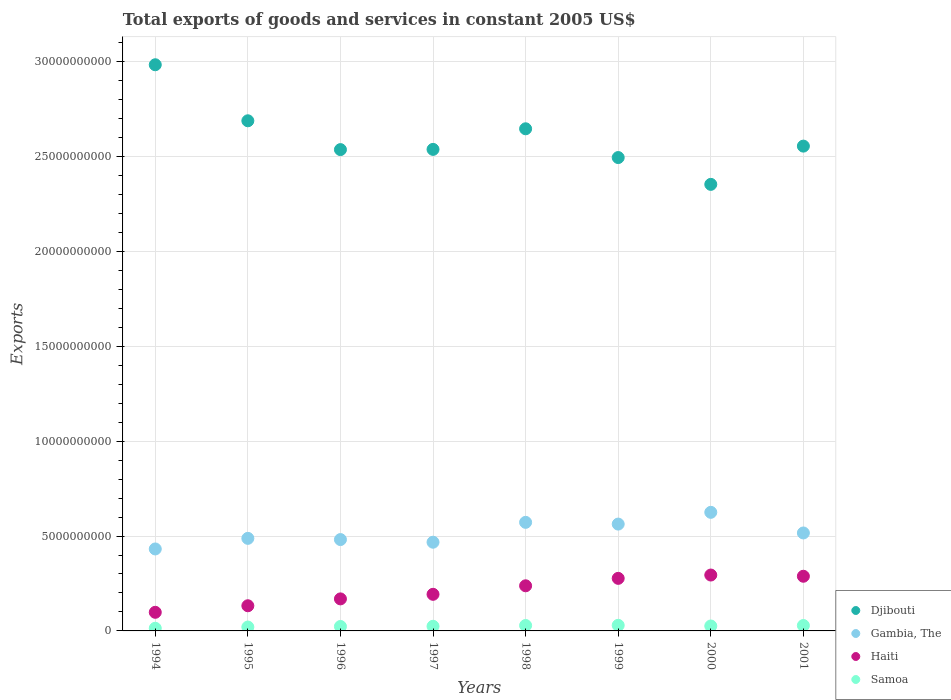Is the number of dotlines equal to the number of legend labels?
Provide a short and direct response. Yes. What is the total exports of goods and services in Haiti in 2000?
Keep it short and to the point. 2.94e+09. Across all years, what is the maximum total exports of goods and services in Gambia, The?
Ensure brevity in your answer.  6.25e+09. Across all years, what is the minimum total exports of goods and services in Gambia, The?
Your answer should be compact. 4.32e+09. In which year was the total exports of goods and services in Haiti maximum?
Ensure brevity in your answer.  2000. In which year was the total exports of goods and services in Djibouti minimum?
Provide a succinct answer. 2000. What is the total total exports of goods and services in Haiti in the graph?
Make the answer very short. 1.69e+1. What is the difference between the total exports of goods and services in Gambia, The in 1996 and that in 2001?
Offer a terse response. -3.48e+08. What is the difference between the total exports of goods and services in Gambia, The in 1997 and the total exports of goods and services in Haiti in 2000?
Provide a short and direct response. 1.73e+09. What is the average total exports of goods and services in Gambia, The per year?
Make the answer very short. 5.18e+09. In the year 2001, what is the difference between the total exports of goods and services in Djibouti and total exports of goods and services in Samoa?
Give a very brief answer. 2.53e+1. In how many years, is the total exports of goods and services in Samoa greater than 22000000000 US$?
Your answer should be very brief. 0. What is the ratio of the total exports of goods and services in Haiti in 1997 to that in 2001?
Provide a short and direct response. 0.67. Is the difference between the total exports of goods and services in Djibouti in 1995 and 2001 greater than the difference between the total exports of goods and services in Samoa in 1995 and 2001?
Ensure brevity in your answer.  Yes. What is the difference between the highest and the second highest total exports of goods and services in Haiti?
Provide a short and direct response. 6.40e+07. What is the difference between the highest and the lowest total exports of goods and services in Samoa?
Your response must be concise. 1.55e+08. In how many years, is the total exports of goods and services in Samoa greater than the average total exports of goods and services in Samoa taken over all years?
Offer a terse response. 5. Is the sum of the total exports of goods and services in Gambia, The in 1996 and 1999 greater than the maximum total exports of goods and services in Haiti across all years?
Provide a short and direct response. Yes. Is it the case that in every year, the sum of the total exports of goods and services in Djibouti and total exports of goods and services in Haiti  is greater than the total exports of goods and services in Samoa?
Offer a very short reply. Yes. Is the total exports of goods and services in Samoa strictly greater than the total exports of goods and services in Haiti over the years?
Offer a very short reply. No. Is the total exports of goods and services in Gambia, The strictly less than the total exports of goods and services in Haiti over the years?
Your answer should be very brief. No. How many dotlines are there?
Provide a succinct answer. 4. What is the difference between two consecutive major ticks on the Y-axis?
Keep it short and to the point. 5.00e+09. Does the graph contain grids?
Your response must be concise. Yes. What is the title of the graph?
Your answer should be very brief. Total exports of goods and services in constant 2005 US$. Does "United States" appear as one of the legend labels in the graph?
Keep it short and to the point. No. What is the label or title of the X-axis?
Provide a short and direct response. Years. What is the label or title of the Y-axis?
Offer a very short reply. Exports. What is the Exports in Djibouti in 1994?
Your response must be concise. 2.98e+1. What is the Exports in Gambia, The in 1994?
Provide a short and direct response. 4.32e+09. What is the Exports of Haiti in 1994?
Give a very brief answer. 9.81e+08. What is the Exports in Samoa in 1994?
Offer a terse response. 1.40e+08. What is the Exports in Djibouti in 1995?
Offer a very short reply. 2.69e+1. What is the Exports in Gambia, The in 1995?
Offer a terse response. 4.88e+09. What is the Exports of Haiti in 1995?
Offer a terse response. 1.33e+09. What is the Exports of Samoa in 1995?
Ensure brevity in your answer.  2.05e+08. What is the Exports of Djibouti in 1996?
Ensure brevity in your answer.  2.54e+1. What is the Exports of Gambia, The in 1996?
Offer a terse response. 4.81e+09. What is the Exports in Haiti in 1996?
Offer a very short reply. 1.69e+09. What is the Exports of Samoa in 1996?
Keep it short and to the point. 2.34e+08. What is the Exports of Djibouti in 1997?
Give a very brief answer. 2.54e+1. What is the Exports of Gambia, The in 1997?
Give a very brief answer. 4.67e+09. What is the Exports of Haiti in 1997?
Your answer should be very brief. 1.93e+09. What is the Exports in Samoa in 1997?
Your answer should be compact. 2.44e+08. What is the Exports of Djibouti in 1998?
Provide a succinct answer. 2.65e+1. What is the Exports of Gambia, The in 1998?
Keep it short and to the point. 5.72e+09. What is the Exports in Haiti in 1998?
Offer a very short reply. 2.38e+09. What is the Exports in Samoa in 1998?
Keep it short and to the point. 2.86e+08. What is the Exports of Djibouti in 1999?
Your response must be concise. 2.49e+1. What is the Exports in Gambia, The in 1999?
Offer a terse response. 5.63e+09. What is the Exports of Haiti in 1999?
Make the answer very short. 2.77e+09. What is the Exports of Samoa in 1999?
Your answer should be very brief. 2.95e+08. What is the Exports of Djibouti in 2000?
Make the answer very short. 2.35e+1. What is the Exports of Gambia, The in 2000?
Provide a short and direct response. 6.25e+09. What is the Exports in Haiti in 2000?
Your response must be concise. 2.94e+09. What is the Exports in Samoa in 2000?
Give a very brief answer. 2.60e+08. What is the Exports of Djibouti in 2001?
Offer a very short reply. 2.55e+1. What is the Exports of Gambia, The in 2001?
Make the answer very short. 5.16e+09. What is the Exports in Haiti in 2001?
Provide a short and direct response. 2.88e+09. What is the Exports in Samoa in 2001?
Provide a short and direct response. 2.85e+08. Across all years, what is the maximum Exports of Djibouti?
Your answer should be compact. 2.98e+1. Across all years, what is the maximum Exports of Gambia, The?
Your answer should be very brief. 6.25e+09. Across all years, what is the maximum Exports in Haiti?
Give a very brief answer. 2.94e+09. Across all years, what is the maximum Exports in Samoa?
Your response must be concise. 2.95e+08. Across all years, what is the minimum Exports in Djibouti?
Ensure brevity in your answer.  2.35e+1. Across all years, what is the minimum Exports in Gambia, The?
Make the answer very short. 4.32e+09. Across all years, what is the minimum Exports of Haiti?
Your answer should be very brief. 9.81e+08. Across all years, what is the minimum Exports in Samoa?
Offer a terse response. 1.40e+08. What is the total Exports of Djibouti in the graph?
Offer a terse response. 2.08e+11. What is the total Exports of Gambia, The in the graph?
Your answer should be very brief. 4.14e+1. What is the total Exports in Haiti in the graph?
Offer a very short reply. 1.69e+1. What is the total Exports of Samoa in the graph?
Your answer should be very brief. 1.95e+09. What is the difference between the Exports in Djibouti in 1994 and that in 1995?
Provide a succinct answer. 2.95e+09. What is the difference between the Exports in Gambia, The in 1994 and that in 1995?
Provide a short and direct response. -5.58e+08. What is the difference between the Exports in Haiti in 1994 and that in 1995?
Keep it short and to the point. -3.45e+08. What is the difference between the Exports of Samoa in 1994 and that in 1995?
Offer a very short reply. -6.46e+07. What is the difference between the Exports in Djibouti in 1994 and that in 1996?
Give a very brief answer. 4.47e+09. What is the difference between the Exports in Gambia, The in 1994 and that in 1996?
Make the answer very short. -4.95e+08. What is the difference between the Exports of Haiti in 1994 and that in 1996?
Offer a very short reply. -7.07e+08. What is the difference between the Exports in Samoa in 1994 and that in 1996?
Offer a very short reply. -9.42e+07. What is the difference between the Exports of Djibouti in 1994 and that in 1997?
Keep it short and to the point. 4.46e+09. What is the difference between the Exports of Gambia, The in 1994 and that in 1997?
Ensure brevity in your answer.  -3.55e+08. What is the difference between the Exports of Haiti in 1994 and that in 1997?
Offer a terse response. -9.48e+08. What is the difference between the Exports of Samoa in 1994 and that in 1997?
Give a very brief answer. -1.04e+08. What is the difference between the Exports of Djibouti in 1994 and that in 1998?
Provide a succinct answer. 3.37e+09. What is the difference between the Exports of Gambia, The in 1994 and that in 1998?
Keep it short and to the point. -1.40e+09. What is the difference between the Exports of Haiti in 1994 and that in 1998?
Your response must be concise. -1.40e+09. What is the difference between the Exports of Samoa in 1994 and that in 1998?
Give a very brief answer. -1.46e+08. What is the difference between the Exports of Djibouti in 1994 and that in 1999?
Your response must be concise. 4.89e+09. What is the difference between the Exports in Gambia, The in 1994 and that in 1999?
Provide a short and direct response. -1.31e+09. What is the difference between the Exports in Haiti in 1994 and that in 1999?
Offer a terse response. -1.79e+09. What is the difference between the Exports in Samoa in 1994 and that in 1999?
Give a very brief answer. -1.55e+08. What is the difference between the Exports in Djibouti in 1994 and that in 2000?
Your response must be concise. 6.30e+09. What is the difference between the Exports in Gambia, The in 1994 and that in 2000?
Offer a very short reply. -1.93e+09. What is the difference between the Exports in Haiti in 1994 and that in 2000?
Provide a short and direct response. -1.96e+09. What is the difference between the Exports of Samoa in 1994 and that in 2000?
Offer a terse response. -1.20e+08. What is the difference between the Exports of Djibouti in 1994 and that in 2001?
Your response must be concise. 4.29e+09. What is the difference between the Exports in Gambia, The in 1994 and that in 2001?
Give a very brief answer. -8.43e+08. What is the difference between the Exports of Haiti in 1994 and that in 2001?
Make the answer very short. -1.90e+09. What is the difference between the Exports in Samoa in 1994 and that in 2001?
Your answer should be compact. -1.45e+08. What is the difference between the Exports of Djibouti in 1995 and that in 1996?
Offer a very short reply. 1.52e+09. What is the difference between the Exports of Gambia, The in 1995 and that in 1996?
Offer a very short reply. 6.37e+07. What is the difference between the Exports in Haiti in 1995 and that in 1996?
Give a very brief answer. -3.62e+08. What is the difference between the Exports of Samoa in 1995 and that in 1996?
Offer a terse response. -2.96e+07. What is the difference between the Exports in Djibouti in 1995 and that in 1997?
Offer a terse response. 1.51e+09. What is the difference between the Exports of Gambia, The in 1995 and that in 1997?
Provide a short and direct response. 2.03e+08. What is the difference between the Exports in Haiti in 1995 and that in 1997?
Ensure brevity in your answer.  -6.03e+08. What is the difference between the Exports in Samoa in 1995 and that in 1997?
Your answer should be very brief. -3.93e+07. What is the difference between the Exports in Djibouti in 1995 and that in 1998?
Provide a succinct answer. 4.22e+08. What is the difference between the Exports in Gambia, The in 1995 and that in 1998?
Keep it short and to the point. -8.44e+08. What is the difference between the Exports of Haiti in 1995 and that in 1998?
Provide a short and direct response. -1.05e+09. What is the difference between the Exports of Samoa in 1995 and that in 1998?
Ensure brevity in your answer.  -8.16e+07. What is the difference between the Exports of Djibouti in 1995 and that in 1999?
Provide a succinct answer. 1.94e+09. What is the difference between the Exports of Gambia, The in 1995 and that in 1999?
Offer a terse response. -7.52e+08. What is the difference between the Exports in Haiti in 1995 and that in 1999?
Keep it short and to the point. -1.44e+09. What is the difference between the Exports of Samoa in 1995 and that in 1999?
Your response must be concise. -9.07e+07. What is the difference between the Exports of Djibouti in 1995 and that in 2000?
Make the answer very short. 3.35e+09. What is the difference between the Exports of Gambia, The in 1995 and that in 2000?
Keep it short and to the point. -1.37e+09. What is the difference between the Exports in Haiti in 1995 and that in 2000?
Ensure brevity in your answer.  -1.62e+09. What is the difference between the Exports in Samoa in 1995 and that in 2000?
Give a very brief answer. -5.55e+07. What is the difference between the Exports in Djibouti in 1995 and that in 2001?
Offer a terse response. 1.34e+09. What is the difference between the Exports in Gambia, The in 1995 and that in 2001?
Ensure brevity in your answer.  -2.84e+08. What is the difference between the Exports of Haiti in 1995 and that in 2001?
Offer a very short reply. -1.56e+09. What is the difference between the Exports of Samoa in 1995 and that in 2001?
Your response must be concise. -8.03e+07. What is the difference between the Exports of Djibouti in 1996 and that in 1997?
Your answer should be compact. -1.16e+07. What is the difference between the Exports of Gambia, The in 1996 and that in 1997?
Provide a succinct answer. 1.40e+08. What is the difference between the Exports in Haiti in 1996 and that in 1997?
Ensure brevity in your answer.  -2.41e+08. What is the difference between the Exports of Samoa in 1996 and that in 1997?
Provide a succinct answer. -9.63e+06. What is the difference between the Exports in Djibouti in 1996 and that in 1998?
Your answer should be very brief. -1.10e+09. What is the difference between the Exports in Gambia, The in 1996 and that in 1998?
Your answer should be very brief. -9.07e+08. What is the difference between the Exports of Haiti in 1996 and that in 1998?
Keep it short and to the point. -6.90e+08. What is the difference between the Exports in Samoa in 1996 and that in 1998?
Your response must be concise. -5.19e+07. What is the difference between the Exports in Djibouti in 1996 and that in 1999?
Offer a very short reply. 4.19e+08. What is the difference between the Exports in Gambia, The in 1996 and that in 1999?
Your answer should be very brief. -8.16e+08. What is the difference between the Exports of Haiti in 1996 and that in 1999?
Your answer should be compact. -1.08e+09. What is the difference between the Exports in Samoa in 1996 and that in 1999?
Your response must be concise. -6.11e+07. What is the difference between the Exports of Djibouti in 1996 and that in 2000?
Provide a succinct answer. 1.83e+09. What is the difference between the Exports in Gambia, The in 1996 and that in 2000?
Make the answer very short. -1.44e+09. What is the difference between the Exports in Haiti in 1996 and that in 2000?
Your answer should be compact. -1.26e+09. What is the difference between the Exports of Samoa in 1996 and that in 2000?
Your response must be concise. -2.59e+07. What is the difference between the Exports in Djibouti in 1996 and that in 2001?
Offer a terse response. -1.84e+08. What is the difference between the Exports in Gambia, The in 1996 and that in 2001?
Provide a succinct answer. -3.48e+08. What is the difference between the Exports in Haiti in 1996 and that in 2001?
Your answer should be compact. -1.19e+09. What is the difference between the Exports of Samoa in 1996 and that in 2001?
Provide a short and direct response. -5.07e+07. What is the difference between the Exports of Djibouti in 1997 and that in 1998?
Make the answer very short. -1.09e+09. What is the difference between the Exports of Gambia, The in 1997 and that in 1998?
Make the answer very short. -1.05e+09. What is the difference between the Exports in Haiti in 1997 and that in 1998?
Keep it short and to the point. -4.49e+08. What is the difference between the Exports in Samoa in 1997 and that in 1998?
Ensure brevity in your answer.  -4.23e+07. What is the difference between the Exports in Djibouti in 1997 and that in 1999?
Your answer should be compact. 4.30e+08. What is the difference between the Exports of Gambia, The in 1997 and that in 1999?
Your answer should be very brief. -9.56e+08. What is the difference between the Exports of Haiti in 1997 and that in 1999?
Provide a succinct answer. -8.41e+08. What is the difference between the Exports in Samoa in 1997 and that in 1999?
Ensure brevity in your answer.  -5.15e+07. What is the difference between the Exports in Djibouti in 1997 and that in 2000?
Give a very brief answer. 1.84e+09. What is the difference between the Exports of Gambia, The in 1997 and that in 2000?
Make the answer very short. -1.57e+09. What is the difference between the Exports in Haiti in 1997 and that in 2000?
Ensure brevity in your answer.  -1.02e+09. What is the difference between the Exports in Samoa in 1997 and that in 2000?
Your response must be concise. -1.63e+07. What is the difference between the Exports of Djibouti in 1997 and that in 2001?
Offer a terse response. -1.72e+08. What is the difference between the Exports in Gambia, The in 1997 and that in 2001?
Ensure brevity in your answer.  -4.87e+08. What is the difference between the Exports of Haiti in 1997 and that in 2001?
Keep it short and to the point. -9.52e+08. What is the difference between the Exports in Samoa in 1997 and that in 2001?
Provide a short and direct response. -4.10e+07. What is the difference between the Exports of Djibouti in 1998 and that in 1999?
Your answer should be very brief. 1.52e+09. What is the difference between the Exports in Gambia, The in 1998 and that in 1999?
Your answer should be very brief. 9.15e+07. What is the difference between the Exports in Haiti in 1998 and that in 1999?
Offer a very short reply. -3.92e+08. What is the difference between the Exports of Samoa in 1998 and that in 1999?
Your response must be concise. -9.18e+06. What is the difference between the Exports in Djibouti in 1998 and that in 2000?
Offer a terse response. 2.93e+09. What is the difference between the Exports in Gambia, The in 1998 and that in 2000?
Give a very brief answer. -5.28e+08. What is the difference between the Exports in Haiti in 1998 and that in 2000?
Ensure brevity in your answer.  -5.67e+08. What is the difference between the Exports in Samoa in 1998 and that in 2000?
Ensure brevity in your answer.  2.60e+07. What is the difference between the Exports in Djibouti in 1998 and that in 2001?
Your response must be concise. 9.13e+08. What is the difference between the Exports in Gambia, The in 1998 and that in 2001?
Your answer should be compact. 5.60e+08. What is the difference between the Exports in Haiti in 1998 and that in 2001?
Make the answer very short. -5.03e+08. What is the difference between the Exports of Samoa in 1998 and that in 2001?
Provide a short and direct response. 1.26e+06. What is the difference between the Exports of Djibouti in 1999 and that in 2000?
Offer a very short reply. 1.41e+09. What is the difference between the Exports of Gambia, The in 1999 and that in 2000?
Make the answer very short. -6.19e+08. What is the difference between the Exports of Haiti in 1999 and that in 2000?
Provide a short and direct response. -1.75e+08. What is the difference between the Exports of Samoa in 1999 and that in 2000?
Provide a short and direct response. 3.52e+07. What is the difference between the Exports in Djibouti in 1999 and that in 2001?
Provide a succinct answer. -6.03e+08. What is the difference between the Exports of Gambia, The in 1999 and that in 2001?
Offer a very short reply. 4.68e+08. What is the difference between the Exports of Haiti in 1999 and that in 2001?
Keep it short and to the point. -1.11e+08. What is the difference between the Exports in Samoa in 1999 and that in 2001?
Provide a short and direct response. 1.04e+07. What is the difference between the Exports in Djibouti in 2000 and that in 2001?
Offer a terse response. -2.02e+09. What is the difference between the Exports of Gambia, The in 2000 and that in 2001?
Give a very brief answer. 1.09e+09. What is the difference between the Exports of Haiti in 2000 and that in 2001?
Make the answer very short. 6.40e+07. What is the difference between the Exports of Samoa in 2000 and that in 2001?
Offer a terse response. -2.48e+07. What is the difference between the Exports of Djibouti in 1994 and the Exports of Gambia, The in 1995?
Provide a succinct answer. 2.50e+1. What is the difference between the Exports in Djibouti in 1994 and the Exports in Haiti in 1995?
Ensure brevity in your answer.  2.85e+1. What is the difference between the Exports in Djibouti in 1994 and the Exports in Samoa in 1995?
Ensure brevity in your answer.  2.96e+1. What is the difference between the Exports in Gambia, The in 1994 and the Exports in Haiti in 1995?
Make the answer very short. 2.99e+09. What is the difference between the Exports in Gambia, The in 1994 and the Exports in Samoa in 1995?
Provide a short and direct response. 4.11e+09. What is the difference between the Exports of Haiti in 1994 and the Exports of Samoa in 1995?
Your answer should be compact. 7.76e+08. What is the difference between the Exports of Djibouti in 1994 and the Exports of Gambia, The in 1996?
Make the answer very short. 2.50e+1. What is the difference between the Exports of Djibouti in 1994 and the Exports of Haiti in 1996?
Keep it short and to the point. 2.81e+1. What is the difference between the Exports of Djibouti in 1994 and the Exports of Samoa in 1996?
Give a very brief answer. 2.96e+1. What is the difference between the Exports in Gambia, The in 1994 and the Exports in Haiti in 1996?
Keep it short and to the point. 2.63e+09. What is the difference between the Exports in Gambia, The in 1994 and the Exports in Samoa in 1996?
Your answer should be compact. 4.09e+09. What is the difference between the Exports in Haiti in 1994 and the Exports in Samoa in 1996?
Your answer should be compact. 7.47e+08. What is the difference between the Exports in Djibouti in 1994 and the Exports in Gambia, The in 1997?
Give a very brief answer. 2.52e+1. What is the difference between the Exports of Djibouti in 1994 and the Exports of Haiti in 1997?
Your answer should be compact. 2.79e+1. What is the difference between the Exports of Djibouti in 1994 and the Exports of Samoa in 1997?
Ensure brevity in your answer.  2.96e+1. What is the difference between the Exports of Gambia, The in 1994 and the Exports of Haiti in 1997?
Keep it short and to the point. 2.39e+09. What is the difference between the Exports in Gambia, The in 1994 and the Exports in Samoa in 1997?
Give a very brief answer. 4.08e+09. What is the difference between the Exports of Haiti in 1994 and the Exports of Samoa in 1997?
Provide a succinct answer. 7.37e+08. What is the difference between the Exports of Djibouti in 1994 and the Exports of Gambia, The in 1998?
Offer a very short reply. 2.41e+1. What is the difference between the Exports of Djibouti in 1994 and the Exports of Haiti in 1998?
Your response must be concise. 2.75e+1. What is the difference between the Exports in Djibouti in 1994 and the Exports in Samoa in 1998?
Keep it short and to the point. 2.96e+1. What is the difference between the Exports of Gambia, The in 1994 and the Exports of Haiti in 1998?
Offer a very short reply. 1.94e+09. What is the difference between the Exports of Gambia, The in 1994 and the Exports of Samoa in 1998?
Ensure brevity in your answer.  4.03e+09. What is the difference between the Exports in Haiti in 1994 and the Exports in Samoa in 1998?
Offer a very short reply. 6.95e+08. What is the difference between the Exports in Djibouti in 1994 and the Exports in Gambia, The in 1999?
Give a very brief answer. 2.42e+1. What is the difference between the Exports in Djibouti in 1994 and the Exports in Haiti in 1999?
Your answer should be very brief. 2.71e+1. What is the difference between the Exports of Djibouti in 1994 and the Exports of Samoa in 1999?
Ensure brevity in your answer.  2.95e+1. What is the difference between the Exports in Gambia, The in 1994 and the Exports in Haiti in 1999?
Your answer should be very brief. 1.55e+09. What is the difference between the Exports in Gambia, The in 1994 and the Exports in Samoa in 1999?
Ensure brevity in your answer.  4.02e+09. What is the difference between the Exports of Haiti in 1994 and the Exports of Samoa in 1999?
Offer a terse response. 6.86e+08. What is the difference between the Exports of Djibouti in 1994 and the Exports of Gambia, The in 2000?
Keep it short and to the point. 2.36e+1. What is the difference between the Exports in Djibouti in 1994 and the Exports in Haiti in 2000?
Keep it short and to the point. 2.69e+1. What is the difference between the Exports in Djibouti in 1994 and the Exports in Samoa in 2000?
Your answer should be compact. 2.96e+1. What is the difference between the Exports of Gambia, The in 1994 and the Exports of Haiti in 2000?
Make the answer very short. 1.37e+09. What is the difference between the Exports of Gambia, The in 1994 and the Exports of Samoa in 2000?
Offer a terse response. 4.06e+09. What is the difference between the Exports of Haiti in 1994 and the Exports of Samoa in 2000?
Make the answer very short. 7.21e+08. What is the difference between the Exports of Djibouti in 1994 and the Exports of Gambia, The in 2001?
Provide a short and direct response. 2.47e+1. What is the difference between the Exports in Djibouti in 1994 and the Exports in Haiti in 2001?
Your answer should be very brief. 2.70e+1. What is the difference between the Exports in Djibouti in 1994 and the Exports in Samoa in 2001?
Offer a very short reply. 2.96e+1. What is the difference between the Exports of Gambia, The in 1994 and the Exports of Haiti in 2001?
Provide a succinct answer. 1.44e+09. What is the difference between the Exports of Gambia, The in 1994 and the Exports of Samoa in 2001?
Offer a very short reply. 4.03e+09. What is the difference between the Exports of Haiti in 1994 and the Exports of Samoa in 2001?
Make the answer very short. 6.96e+08. What is the difference between the Exports in Djibouti in 1995 and the Exports in Gambia, The in 1996?
Keep it short and to the point. 2.21e+1. What is the difference between the Exports in Djibouti in 1995 and the Exports in Haiti in 1996?
Offer a very short reply. 2.52e+1. What is the difference between the Exports of Djibouti in 1995 and the Exports of Samoa in 1996?
Provide a short and direct response. 2.66e+1. What is the difference between the Exports of Gambia, The in 1995 and the Exports of Haiti in 1996?
Offer a very short reply. 3.19e+09. What is the difference between the Exports in Gambia, The in 1995 and the Exports in Samoa in 1996?
Ensure brevity in your answer.  4.64e+09. What is the difference between the Exports in Haiti in 1995 and the Exports in Samoa in 1996?
Your response must be concise. 1.09e+09. What is the difference between the Exports of Djibouti in 1995 and the Exports of Gambia, The in 1997?
Keep it short and to the point. 2.22e+1. What is the difference between the Exports in Djibouti in 1995 and the Exports in Haiti in 1997?
Your response must be concise. 2.50e+1. What is the difference between the Exports of Djibouti in 1995 and the Exports of Samoa in 1997?
Make the answer very short. 2.66e+1. What is the difference between the Exports in Gambia, The in 1995 and the Exports in Haiti in 1997?
Provide a succinct answer. 2.95e+09. What is the difference between the Exports of Gambia, The in 1995 and the Exports of Samoa in 1997?
Make the answer very short. 4.63e+09. What is the difference between the Exports in Haiti in 1995 and the Exports in Samoa in 1997?
Offer a very short reply. 1.08e+09. What is the difference between the Exports of Djibouti in 1995 and the Exports of Gambia, The in 1998?
Provide a succinct answer. 2.12e+1. What is the difference between the Exports in Djibouti in 1995 and the Exports in Haiti in 1998?
Make the answer very short. 2.45e+1. What is the difference between the Exports of Djibouti in 1995 and the Exports of Samoa in 1998?
Provide a short and direct response. 2.66e+1. What is the difference between the Exports of Gambia, The in 1995 and the Exports of Haiti in 1998?
Offer a terse response. 2.50e+09. What is the difference between the Exports in Gambia, The in 1995 and the Exports in Samoa in 1998?
Give a very brief answer. 4.59e+09. What is the difference between the Exports in Haiti in 1995 and the Exports in Samoa in 1998?
Provide a succinct answer. 1.04e+09. What is the difference between the Exports of Djibouti in 1995 and the Exports of Gambia, The in 1999?
Your answer should be compact. 2.13e+1. What is the difference between the Exports in Djibouti in 1995 and the Exports in Haiti in 1999?
Offer a terse response. 2.41e+1. What is the difference between the Exports in Djibouti in 1995 and the Exports in Samoa in 1999?
Provide a succinct answer. 2.66e+1. What is the difference between the Exports in Gambia, The in 1995 and the Exports in Haiti in 1999?
Make the answer very short. 2.11e+09. What is the difference between the Exports in Gambia, The in 1995 and the Exports in Samoa in 1999?
Your response must be concise. 4.58e+09. What is the difference between the Exports of Haiti in 1995 and the Exports of Samoa in 1999?
Offer a terse response. 1.03e+09. What is the difference between the Exports of Djibouti in 1995 and the Exports of Gambia, The in 2000?
Make the answer very short. 2.06e+1. What is the difference between the Exports in Djibouti in 1995 and the Exports in Haiti in 2000?
Provide a short and direct response. 2.39e+1. What is the difference between the Exports in Djibouti in 1995 and the Exports in Samoa in 2000?
Ensure brevity in your answer.  2.66e+1. What is the difference between the Exports of Gambia, The in 1995 and the Exports of Haiti in 2000?
Your response must be concise. 1.93e+09. What is the difference between the Exports in Gambia, The in 1995 and the Exports in Samoa in 2000?
Keep it short and to the point. 4.62e+09. What is the difference between the Exports of Haiti in 1995 and the Exports of Samoa in 2000?
Provide a short and direct response. 1.07e+09. What is the difference between the Exports in Djibouti in 1995 and the Exports in Gambia, The in 2001?
Your answer should be compact. 2.17e+1. What is the difference between the Exports in Djibouti in 1995 and the Exports in Haiti in 2001?
Your answer should be compact. 2.40e+1. What is the difference between the Exports of Djibouti in 1995 and the Exports of Samoa in 2001?
Keep it short and to the point. 2.66e+1. What is the difference between the Exports in Gambia, The in 1995 and the Exports in Haiti in 2001?
Your response must be concise. 2.00e+09. What is the difference between the Exports of Gambia, The in 1995 and the Exports of Samoa in 2001?
Provide a succinct answer. 4.59e+09. What is the difference between the Exports in Haiti in 1995 and the Exports in Samoa in 2001?
Your answer should be compact. 1.04e+09. What is the difference between the Exports of Djibouti in 1996 and the Exports of Gambia, The in 1997?
Keep it short and to the point. 2.07e+1. What is the difference between the Exports of Djibouti in 1996 and the Exports of Haiti in 1997?
Keep it short and to the point. 2.34e+1. What is the difference between the Exports in Djibouti in 1996 and the Exports in Samoa in 1997?
Offer a very short reply. 2.51e+1. What is the difference between the Exports in Gambia, The in 1996 and the Exports in Haiti in 1997?
Ensure brevity in your answer.  2.89e+09. What is the difference between the Exports in Gambia, The in 1996 and the Exports in Samoa in 1997?
Provide a short and direct response. 4.57e+09. What is the difference between the Exports in Haiti in 1996 and the Exports in Samoa in 1997?
Make the answer very short. 1.44e+09. What is the difference between the Exports of Djibouti in 1996 and the Exports of Gambia, The in 1998?
Your answer should be very brief. 1.96e+1. What is the difference between the Exports of Djibouti in 1996 and the Exports of Haiti in 1998?
Your answer should be compact. 2.30e+1. What is the difference between the Exports of Djibouti in 1996 and the Exports of Samoa in 1998?
Your response must be concise. 2.51e+1. What is the difference between the Exports of Gambia, The in 1996 and the Exports of Haiti in 1998?
Provide a succinct answer. 2.44e+09. What is the difference between the Exports of Gambia, The in 1996 and the Exports of Samoa in 1998?
Give a very brief answer. 4.53e+09. What is the difference between the Exports of Haiti in 1996 and the Exports of Samoa in 1998?
Provide a succinct answer. 1.40e+09. What is the difference between the Exports of Djibouti in 1996 and the Exports of Gambia, The in 1999?
Your answer should be very brief. 1.97e+1. What is the difference between the Exports in Djibouti in 1996 and the Exports in Haiti in 1999?
Your answer should be compact. 2.26e+1. What is the difference between the Exports of Djibouti in 1996 and the Exports of Samoa in 1999?
Provide a succinct answer. 2.51e+1. What is the difference between the Exports of Gambia, The in 1996 and the Exports of Haiti in 1999?
Make the answer very short. 2.04e+09. What is the difference between the Exports of Gambia, The in 1996 and the Exports of Samoa in 1999?
Your answer should be compact. 4.52e+09. What is the difference between the Exports of Haiti in 1996 and the Exports of Samoa in 1999?
Your response must be concise. 1.39e+09. What is the difference between the Exports in Djibouti in 1996 and the Exports in Gambia, The in 2000?
Give a very brief answer. 1.91e+1. What is the difference between the Exports of Djibouti in 1996 and the Exports of Haiti in 2000?
Ensure brevity in your answer.  2.24e+1. What is the difference between the Exports of Djibouti in 1996 and the Exports of Samoa in 2000?
Your response must be concise. 2.51e+1. What is the difference between the Exports of Gambia, The in 1996 and the Exports of Haiti in 2000?
Ensure brevity in your answer.  1.87e+09. What is the difference between the Exports in Gambia, The in 1996 and the Exports in Samoa in 2000?
Keep it short and to the point. 4.55e+09. What is the difference between the Exports in Haiti in 1996 and the Exports in Samoa in 2000?
Your response must be concise. 1.43e+09. What is the difference between the Exports in Djibouti in 1996 and the Exports in Gambia, The in 2001?
Give a very brief answer. 2.02e+1. What is the difference between the Exports of Djibouti in 1996 and the Exports of Haiti in 2001?
Your response must be concise. 2.25e+1. What is the difference between the Exports of Djibouti in 1996 and the Exports of Samoa in 2001?
Your answer should be compact. 2.51e+1. What is the difference between the Exports in Gambia, The in 1996 and the Exports in Haiti in 2001?
Keep it short and to the point. 1.93e+09. What is the difference between the Exports in Gambia, The in 1996 and the Exports in Samoa in 2001?
Provide a succinct answer. 4.53e+09. What is the difference between the Exports in Haiti in 1996 and the Exports in Samoa in 2001?
Offer a terse response. 1.40e+09. What is the difference between the Exports of Djibouti in 1997 and the Exports of Gambia, The in 1998?
Your answer should be compact. 1.97e+1. What is the difference between the Exports in Djibouti in 1997 and the Exports in Haiti in 1998?
Your answer should be very brief. 2.30e+1. What is the difference between the Exports of Djibouti in 1997 and the Exports of Samoa in 1998?
Provide a succinct answer. 2.51e+1. What is the difference between the Exports of Gambia, The in 1997 and the Exports of Haiti in 1998?
Keep it short and to the point. 2.30e+09. What is the difference between the Exports in Gambia, The in 1997 and the Exports in Samoa in 1998?
Keep it short and to the point. 4.39e+09. What is the difference between the Exports of Haiti in 1997 and the Exports of Samoa in 1998?
Give a very brief answer. 1.64e+09. What is the difference between the Exports of Djibouti in 1997 and the Exports of Gambia, The in 1999?
Provide a succinct answer. 1.97e+1. What is the difference between the Exports in Djibouti in 1997 and the Exports in Haiti in 1999?
Provide a succinct answer. 2.26e+1. What is the difference between the Exports in Djibouti in 1997 and the Exports in Samoa in 1999?
Offer a very short reply. 2.51e+1. What is the difference between the Exports in Gambia, The in 1997 and the Exports in Haiti in 1999?
Offer a terse response. 1.90e+09. What is the difference between the Exports of Gambia, The in 1997 and the Exports of Samoa in 1999?
Keep it short and to the point. 4.38e+09. What is the difference between the Exports of Haiti in 1997 and the Exports of Samoa in 1999?
Keep it short and to the point. 1.63e+09. What is the difference between the Exports in Djibouti in 1997 and the Exports in Gambia, The in 2000?
Provide a succinct answer. 1.91e+1. What is the difference between the Exports of Djibouti in 1997 and the Exports of Haiti in 2000?
Your response must be concise. 2.24e+1. What is the difference between the Exports of Djibouti in 1997 and the Exports of Samoa in 2000?
Provide a succinct answer. 2.51e+1. What is the difference between the Exports in Gambia, The in 1997 and the Exports in Haiti in 2000?
Provide a short and direct response. 1.73e+09. What is the difference between the Exports in Gambia, The in 1997 and the Exports in Samoa in 2000?
Your response must be concise. 4.41e+09. What is the difference between the Exports in Haiti in 1997 and the Exports in Samoa in 2000?
Your response must be concise. 1.67e+09. What is the difference between the Exports in Djibouti in 1997 and the Exports in Gambia, The in 2001?
Provide a short and direct response. 2.02e+1. What is the difference between the Exports in Djibouti in 1997 and the Exports in Haiti in 2001?
Your answer should be very brief. 2.25e+1. What is the difference between the Exports in Djibouti in 1997 and the Exports in Samoa in 2001?
Ensure brevity in your answer.  2.51e+1. What is the difference between the Exports of Gambia, The in 1997 and the Exports of Haiti in 2001?
Offer a terse response. 1.79e+09. What is the difference between the Exports of Gambia, The in 1997 and the Exports of Samoa in 2001?
Offer a very short reply. 4.39e+09. What is the difference between the Exports in Haiti in 1997 and the Exports in Samoa in 2001?
Make the answer very short. 1.64e+09. What is the difference between the Exports of Djibouti in 1998 and the Exports of Gambia, The in 1999?
Your response must be concise. 2.08e+1. What is the difference between the Exports of Djibouti in 1998 and the Exports of Haiti in 1999?
Make the answer very short. 2.37e+1. What is the difference between the Exports in Djibouti in 1998 and the Exports in Samoa in 1999?
Provide a succinct answer. 2.62e+1. What is the difference between the Exports in Gambia, The in 1998 and the Exports in Haiti in 1999?
Give a very brief answer. 2.95e+09. What is the difference between the Exports in Gambia, The in 1998 and the Exports in Samoa in 1999?
Your answer should be very brief. 5.43e+09. What is the difference between the Exports of Haiti in 1998 and the Exports of Samoa in 1999?
Ensure brevity in your answer.  2.08e+09. What is the difference between the Exports in Djibouti in 1998 and the Exports in Gambia, The in 2000?
Your answer should be compact. 2.02e+1. What is the difference between the Exports in Djibouti in 1998 and the Exports in Haiti in 2000?
Give a very brief answer. 2.35e+1. What is the difference between the Exports in Djibouti in 1998 and the Exports in Samoa in 2000?
Ensure brevity in your answer.  2.62e+1. What is the difference between the Exports in Gambia, The in 1998 and the Exports in Haiti in 2000?
Offer a terse response. 2.78e+09. What is the difference between the Exports of Gambia, The in 1998 and the Exports of Samoa in 2000?
Your answer should be compact. 5.46e+09. What is the difference between the Exports of Haiti in 1998 and the Exports of Samoa in 2000?
Provide a succinct answer. 2.12e+09. What is the difference between the Exports in Djibouti in 1998 and the Exports in Gambia, The in 2001?
Make the answer very short. 2.13e+1. What is the difference between the Exports of Djibouti in 1998 and the Exports of Haiti in 2001?
Your response must be concise. 2.36e+1. What is the difference between the Exports in Djibouti in 1998 and the Exports in Samoa in 2001?
Give a very brief answer. 2.62e+1. What is the difference between the Exports in Gambia, The in 1998 and the Exports in Haiti in 2001?
Provide a succinct answer. 2.84e+09. What is the difference between the Exports of Gambia, The in 1998 and the Exports of Samoa in 2001?
Your answer should be very brief. 5.44e+09. What is the difference between the Exports of Haiti in 1998 and the Exports of Samoa in 2001?
Offer a terse response. 2.09e+09. What is the difference between the Exports of Djibouti in 1999 and the Exports of Gambia, The in 2000?
Provide a short and direct response. 1.87e+1. What is the difference between the Exports of Djibouti in 1999 and the Exports of Haiti in 2000?
Ensure brevity in your answer.  2.20e+1. What is the difference between the Exports of Djibouti in 1999 and the Exports of Samoa in 2000?
Provide a short and direct response. 2.47e+1. What is the difference between the Exports of Gambia, The in 1999 and the Exports of Haiti in 2000?
Ensure brevity in your answer.  2.69e+09. What is the difference between the Exports in Gambia, The in 1999 and the Exports in Samoa in 2000?
Offer a very short reply. 5.37e+09. What is the difference between the Exports of Haiti in 1999 and the Exports of Samoa in 2000?
Your response must be concise. 2.51e+09. What is the difference between the Exports in Djibouti in 1999 and the Exports in Gambia, The in 2001?
Your response must be concise. 1.98e+1. What is the difference between the Exports of Djibouti in 1999 and the Exports of Haiti in 2001?
Your response must be concise. 2.21e+1. What is the difference between the Exports of Djibouti in 1999 and the Exports of Samoa in 2001?
Provide a short and direct response. 2.47e+1. What is the difference between the Exports in Gambia, The in 1999 and the Exports in Haiti in 2001?
Make the answer very short. 2.75e+09. What is the difference between the Exports of Gambia, The in 1999 and the Exports of Samoa in 2001?
Offer a very short reply. 5.35e+09. What is the difference between the Exports in Haiti in 1999 and the Exports in Samoa in 2001?
Make the answer very short. 2.49e+09. What is the difference between the Exports in Djibouti in 2000 and the Exports in Gambia, The in 2001?
Offer a terse response. 1.84e+1. What is the difference between the Exports in Djibouti in 2000 and the Exports in Haiti in 2001?
Make the answer very short. 2.07e+1. What is the difference between the Exports in Djibouti in 2000 and the Exports in Samoa in 2001?
Ensure brevity in your answer.  2.32e+1. What is the difference between the Exports in Gambia, The in 2000 and the Exports in Haiti in 2001?
Give a very brief answer. 3.37e+09. What is the difference between the Exports in Gambia, The in 2000 and the Exports in Samoa in 2001?
Offer a very short reply. 5.96e+09. What is the difference between the Exports of Haiti in 2000 and the Exports of Samoa in 2001?
Make the answer very short. 2.66e+09. What is the average Exports in Djibouti per year?
Your answer should be very brief. 2.60e+1. What is the average Exports in Gambia, The per year?
Keep it short and to the point. 5.18e+09. What is the average Exports in Haiti per year?
Keep it short and to the point. 2.11e+09. What is the average Exports in Samoa per year?
Offer a very short reply. 2.44e+08. In the year 1994, what is the difference between the Exports in Djibouti and Exports in Gambia, The?
Ensure brevity in your answer.  2.55e+1. In the year 1994, what is the difference between the Exports in Djibouti and Exports in Haiti?
Your answer should be compact. 2.89e+1. In the year 1994, what is the difference between the Exports in Djibouti and Exports in Samoa?
Keep it short and to the point. 2.97e+1. In the year 1994, what is the difference between the Exports in Gambia, The and Exports in Haiti?
Offer a very short reply. 3.34e+09. In the year 1994, what is the difference between the Exports in Gambia, The and Exports in Samoa?
Your answer should be very brief. 4.18e+09. In the year 1994, what is the difference between the Exports of Haiti and Exports of Samoa?
Your answer should be very brief. 8.41e+08. In the year 1995, what is the difference between the Exports in Djibouti and Exports in Gambia, The?
Offer a terse response. 2.20e+1. In the year 1995, what is the difference between the Exports in Djibouti and Exports in Haiti?
Provide a succinct answer. 2.56e+1. In the year 1995, what is the difference between the Exports of Djibouti and Exports of Samoa?
Make the answer very short. 2.67e+1. In the year 1995, what is the difference between the Exports of Gambia, The and Exports of Haiti?
Give a very brief answer. 3.55e+09. In the year 1995, what is the difference between the Exports of Gambia, The and Exports of Samoa?
Offer a very short reply. 4.67e+09. In the year 1995, what is the difference between the Exports of Haiti and Exports of Samoa?
Provide a succinct answer. 1.12e+09. In the year 1996, what is the difference between the Exports in Djibouti and Exports in Gambia, The?
Offer a terse response. 2.06e+1. In the year 1996, what is the difference between the Exports in Djibouti and Exports in Haiti?
Your answer should be very brief. 2.37e+1. In the year 1996, what is the difference between the Exports in Djibouti and Exports in Samoa?
Ensure brevity in your answer.  2.51e+1. In the year 1996, what is the difference between the Exports of Gambia, The and Exports of Haiti?
Give a very brief answer. 3.13e+09. In the year 1996, what is the difference between the Exports of Gambia, The and Exports of Samoa?
Offer a terse response. 4.58e+09. In the year 1996, what is the difference between the Exports in Haiti and Exports in Samoa?
Keep it short and to the point. 1.45e+09. In the year 1997, what is the difference between the Exports of Djibouti and Exports of Gambia, The?
Offer a very short reply. 2.07e+1. In the year 1997, what is the difference between the Exports in Djibouti and Exports in Haiti?
Offer a very short reply. 2.34e+1. In the year 1997, what is the difference between the Exports in Djibouti and Exports in Samoa?
Give a very brief answer. 2.51e+1. In the year 1997, what is the difference between the Exports of Gambia, The and Exports of Haiti?
Your answer should be compact. 2.75e+09. In the year 1997, what is the difference between the Exports in Gambia, The and Exports in Samoa?
Keep it short and to the point. 4.43e+09. In the year 1997, what is the difference between the Exports in Haiti and Exports in Samoa?
Make the answer very short. 1.69e+09. In the year 1998, what is the difference between the Exports in Djibouti and Exports in Gambia, The?
Give a very brief answer. 2.07e+1. In the year 1998, what is the difference between the Exports in Djibouti and Exports in Haiti?
Keep it short and to the point. 2.41e+1. In the year 1998, what is the difference between the Exports of Djibouti and Exports of Samoa?
Offer a very short reply. 2.62e+1. In the year 1998, what is the difference between the Exports in Gambia, The and Exports in Haiti?
Your answer should be compact. 3.34e+09. In the year 1998, what is the difference between the Exports of Gambia, The and Exports of Samoa?
Ensure brevity in your answer.  5.44e+09. In the year 1998, what is the difference between the Exports of Haiti and Exports of Samoa?
Your answer should be compact. 2.09e+09. In the year 1999, what is the difference between the Exports of Djibouti and Exports of Gambia, The?
Make the answer very short. 1.93e+1. In the year 1999, what is the difference between the Exports in Djibouti and Exports in Haiti?
Keep it short and to the point. 2.22e+1. In the year 1999, what is the difference between the Exports of Djibouti and Exports of Samoa?
Offer a very short reply. 2.47e+1. In the year 1999, what is the difference between the Exports of Gambia, The and Exports of Haiti?
Your answer should be very brief. 2.86e+09. In the year 1999, what is the difference between the Exports in Gambia, The and Exports in Samoa?
Your response must be concise. 5.33e+09. In the year 1999, what is the difference between the Exports in Haiti and Exports in Samoa?
Offer a very short reply. 2.47e+09. In the year 2000, what is the difference between the Exports of Djibouti and Exports of Gambia, The?
Offer a very short reply. 1.73e+1. In the year 2000, what is the difference between the Exports of Djibouti and Exports of Haiti?
Offer a terse response. 2.06e+1. In the year 2000, what is the difference between the Exports of Djibouti and Exports of Samoa?
Provide a succinct answer. 2.33e+1. In the year 2000, what is the difference between the Exports in Gambia, The and Exports in Haiti?
Offer a terse response. 3.30e+09. In the year 2000, what is the difference between the Exports in Gambia, The and Exports in Samoa?
Give a very brief answer. 5.99e+09. In the year 2000, what is the difference between the Exports in Haiti and Exports in Samoa?
Ensure brevity in your answer.  2.68e+09. In the year 2001, what is the difference between the Exports of Djibouti and Exports of Gambia, The?
Your answer should be very brief. 2.04e+1. In the year 2001, what is the difference between the Exports in Djibouti and Exports in Haiti?
Give a very brief answer. 2.27e+1. In the year 2001, what is the difference between the Exports of Djibouti and Exports of Samoa?
Ensure brevity in your answer.  2.53e+1. In the year 2001, what is the difference between the Exports in Gambia, The and Exports in Haiti?
Your answer should be very brief. 2.28e+09. In the year 2001, what is the difference between the Exports of Gambia, The and Exports of Samoa?
Give a very brief answer. 4.88e+09. In the year 2001, what is the difference between the Exports in Haiti and Exports in Samoa?
Offer a very short reply. 2.60e+09. What is the ratio of the Exports of Djibouti in 1994 to that in 1995?
Ensure brevity in your answer.  1.11. What is the ratio of the Exports in Gambia, The in 1994 to that in 1995?
Your answer should be compact. 0.89. What is the ratio of the Exports in Haiti in 1994 to that in 1995?
Offer a very short reply. 0.74. What is the ratio of the Exports of Samoa in 1994 to that in 1995?
Offer a very short reply. 0.68. What is the ratio of the Exports in Djibouti in 1994 to that in 1996?
Provide a short and direct response. 1.18. What is the ratio of the Exports of Gambia, The in 1994 to that in 1996?
Your response must be concise. 0.9. What is the ratio of the Exports in Haiti in 1994 to that in 1996?
Keep it short and to the point. 0.58. What is the ratio of the Exports in Samoa in 1994 to that in 1996?
Offer a very short reply. 0.6. What is the ratio of the Exports of Djibouti in 1994 to that in 1997?
Provide a short and direct response. 1.18. What is the ratio of the Exports in Gambia, The in 1994 to that in 1997?
Ensure brevity in your answer.  0.92. What is the ratio of the Exports of Haiti in 1994 to that in 1997?
Your response must be concise. 0.51. What is the ratio of the Exports of Samoa in 1994 to that in 1997?
Provide a short and direct response. 0.57. What is the ratio of the Exports of Djibouti in 1994 to that in 1998?
Your answer should be very brief. 1.13. What is the ratio of the Exports of Gambia, The in 1994 to that in 1998?
Make the answer very short. 0.75. What is the ratio of the Exports in Haiti in 1994 to that in 1998?
Make the answer very short. 0.41. What is the ratio of the Exports of Samoa in 1994 to that in 1998?
Provide a short and direct response. 0.49. What is the ratio of the Exports of Djibouti in 1994 to that in 1999?
Keep it short and to the point. 1.2. What is the ratio of the Exports in Gambia, The in 1994 to that in 1999?
Your answer should be very brief. 0.77. What is the ratio of the Exports in Haiti in 1994 to that in 1999?
Offer a terse response. 0.35. What is the ratio of the Exports of Samoa in 1994 to that in 1999?
Make the answer very short. 0.47. What is the ratio of the Exports of Djibouti in 1994 to that in 2000?
Offer a very short reply. 1.27. What is the ratio of the Exports of Gambia, The in 1994 to that in 2000?
Provide a succinct answer. 0.69. What is the ratio of the Exports of Haiti in 1994 to that in 2000?
Your answer should be very brief. 0.33. What is the ratio of the Exports of Samoa in 1994 to that in 2000?
Your answer should be compact. 0.54. What is the ratio of the Exports of Djibouti in 1994 to that in 2001?
Your answer should be very brief. 1.17. What is the ratio of the Exports in Gambia, The in 1994 to that in 2001?
Offer a very short reply. 0.84. What is the ratio of the Exports in Haiti in 1994 to that in 2001?
Make the answer very short. 0.34. What is the ratio of the Exports of Samoa in 1994 to that in 2001?
Offer a terse response. 0.49. What is the ratio of the Exports of Djibouti in 1995 to that in 1996?
Provide a short and direct response. 1.06. What is the ratio of the Exports of Gambia, The in 1995 to that in 1996?
Make the answer very short. 1.01. What is the ratio of the Exports of Haiti in 1995 to that in 1996?
Ensure brevity in your answer.  0.79. What is the ratio of the Exports in Samoa in 1995 to that in 1996?
Offer a terse response. 0.87. What is the ratio of the Exports in Djibouti in 1995 to that in 1997?
Give a very brief answer. 1.06. What is the ratio of the Exports in Gambia, The in 1995 to that in 1997?
Your answer should be very brief. 1.04. What is the ratio of the Exports in Haiti in 1995 to that in 1997?
Give a very brief answer. 0.69. What is the ratio of the Exports of Samoa in 1995 to that in 1997?
Provide a succinct answer. 0.84. What is the ratio of the Exports in Djibouti in 1995 to that in 1998?
Offer a very short reply. 1.02. What is the ratio of the Exports of Gambia, The in 1995 to that in 1998?
Provide a short and direct response. 0.85. What is the ratio of the Exports in Haiti in 1995 to that in 1998?
Your answer should be compact. 0.56. What is the ratio of the Exports of Samoa in 1995 to that in 1998?
Make the answer very short. 0.72. What is the ratio of the Exports of Djibouti in 1995 to that in 1999?
Provide a short and direct response. 1.08. What is the ratio of the Exports in Gambia, The in 1995 to that in 1999?
Give a very brief answer. 0.87. What is the ratio of the Exports in Haiti in 1995 to that in 1999?
Offer a very short reply. 0.48. What is the ratio of the Exports of Samoa in 1995 to that in 1999?
Provide a succinct answer. 0.69. What is the ratio of the Exports in Djibouti in 1995 to that in 2000?
Your answer should be very brief. 1.14. What is the ratio of the Exports in Gambia, The in 1995 to that in 2000?
Make the answer very short. 0.78. What is the ratio of the Exports in Haiti in 1995 to that in 2000?
Keep it short and to the point. 0.45. What is the ratio of the Exports in Samoa in 1995 to that in 2000?
Offer a very short reply. 0.79. What is the ratio of the Exports of Djibouti in 1995 to that in 2001?
Make the answer very short. 1.05. What is the ratio of the Exports of Gambia, The in 1995 to that in 2001?
Your response must be concise. 0.94. What is the ratio of the Exports in Haiti in 1995 to that in 2001?
Keep it short and to the point. 0.46. What is the ratio of the Exports in Samoa in 1995 to that in 2001?
Your answer should be very brief. 0.72. What is the ratio of the Exports in Gambia, The in 1996 to that in 1997?
Give a very brief answer. 1.03. What is the ratio of the Exports in Haiti in 1996 to that in 1997?
Ensure brevity in your answer.  0.88. What is the ratio of the Exports in Samoa in 1996 to that in 1997?
Your answer should be very brief. 0.96. What is the ratio of the Exports in Djibouti in 1996 to that in 1998?
Give a very brief answer. 0.96. What is the ratio of the Exports in Gambia, The in 1996 to that in 1998?
Give a very brief answer. 0.84. What is the ratio of the Exports of Haiti in 1996 to that in 1998?
Provide a succinct answer. 0.71. What is the ratio of the Exports in Samoa in 1996 to that in 1998?
Your answer should be very brief. 0.82. What is the ratio of the Exports of Djibouti in 1996 to that in 1999?
Offer a terse response. 1.02. What is the ratio of the Exports in Gambia, The in 1996 to that in 1999?
Provide a succinct answer. 0.86. What is the ratio of the Exports of Haiti in 1996 to that in 1999?
Your answer should be very brief. 0.61. What is the ratio of the Exports in Samoa in 1996 to that in 1999?
Ensure brevity in your answer.  0.79. What is the ratio of the Exports in Djibouti in 1996 to that in 2000?
Your response must be concise. 1.08. What is the ratio of the Exports of Gambia, The in 1996 to that in 2000?
Your answer should be compact. 0.77. What is the ratio of the Exports in Haiti in 1996 to that in 2000?
Your answer should be very brief. 0.57. What is the ratio of the Exports in Samoa in 1996 to that in 2000?
Your response must be concise. 0.9. What is the ratio of the Exports of Djibouti in 1996 to that in 2001?
Offer a very short reply. 0.99. What is the ratio of the Exports in Gambia, The in 1996 to that in 2001?
Make the answer very short. 0.93. What is the ratio of the Exports of Haiti in 1996 to that in 2001?
Your response must be concise. 0.59. What is the ratio of the Exports of Samoa in 1996 to that in 2001?
Offer a terse response. 0.82. What is the ratio of the Exports in Djibouti in 1997 to that in 1998?
Provide a short and direct response. 0.96. What is the ratio of the Exports of Gambia, The in 1997 to that in 1998?
Provide a short and direct response. 0.82. What is the ratio of the Exports in Haiti in 1997 to that in 1998?
Give a very brief answer. 0.81. What is the ratio of the Exports of Samoa in 1997 to that in 1998?
Your answer should be very brief. 0.85. What is the ratio of the Exports of Djibouti in 1997 to that in 1999?
Your answer should be compact. 1.02. What is the ratio of the Exports in Gambia, The in 1997 to that in 1999?
Keep it short and to the point. 0.83. What is the ratio of the Exports in Haiti in 1997 to that in 1999?
Keep it short and to the point. 0.7. What is the ratio of the Exports in Samoa in 1997 to that in 1999?
Ensure brevity in your answer.  0.83. What is the ratio of the Exports in Djibouti in 1997 to that in 2000?
Your answer should be very brief. 1.08. What is the ratio of the Exports of Gambia, The in 1997 to that in 2000?
Provide a succinct answer. 0.75. What is the ratio of the Exports of Haiti in 1997 to that in 2000?
Ensure brevity in your answer.  0.66. What is the ratio of the Exports of Samoa in 1997 to that in 2000?
Give a very brief answer. 0.94. What is the ratio of the Exports of Gambia, The in 1997 to that in 2001?
Offer a terse response. 0.91. What is the ratio of the Exports of Haiti in 1997 to that in 2001?
Offer a very short reply. 0.67. What is the ratio of the Exports of Samoa in 1997 to that in 2001?
Keep it short and to the point. 0.86. What is the ratio of the Exports of Djibouti in 1998 to that in 1999?
Make the answer very short. 1.06. What is the ratio of the Exports in Gambia, The in 1998 to that in 1999?
Give a very brief answer. 1.02. What is the ratio of the Exports of Haiti in 1998 to that in 1999?
Keep it short and to the point. 0.86. What is the ratio of the Exports of Samoa in 1998 to that in 1999?
Make the answer very short. 0.97. What is the ratio of the Exports in Djibouti in 1998 to that in 2000?
Your answer should be compact. 1.12. What is the ratio of the Exports of Gambia, The in 1998 to that in 2000?
Keep it short and to the point. 0.92. What is the ratio of the Exports in Haiti in 1998 to that in 2000?
Your answer should be very brief. 0.81. What is the ratio of the Exports of Samoa in 1998 to that in 2000?
Provide a short and direct response. 1.1. What is the ratio of the Exports in Djibouti in 1998 to that in 2001?
Provide a succinct answer. 1.04. What is the ratio of the Exports in Gambia, The in 1998 to that in 2001?
Keep it short and to the point. 1.11. What is the ratio of the Exports of Haiti in 1998 to that in 2001?
Keep it short and to the point. 0.83. What is the ratio of the Exports in Samoa in 1998 to that in 2001?
Provide a succinct answer. 1. What is the ratio of the Exports in Djibouti in 1999 to that in 2000?
Your response must be concise. 1.06. What is the ratio of the Exports of Gambia, The in 1999 to that in 2000?
Offer a terse response. 0.9. What is the ratio of the Exports of Haiti in 1999 to that in 2000?
Make the answer very short. 0.94. What is the ratio of the Exports of Samoa in 1999 to that in 2000?
Keep it short and to the point. 1.14. What is the ratio of the Exports in Djibouti in 1999 to that in 2001?
Give a very brief answer. 0.98. What is the ratio of the Exports in Gambia, The in 1999 to that in 2001?
Offer a terse response. 1.09. What is the ratio of the Exports in Haiti in 1999 to that in 2001?
Provide a short and direct response. 0.96. What is the ratio of the Exports in Samoa in 1999 to that in 2001?
Offer a terse response. 1.04. What is the ratio of the Exports in Djibouti in 2000 to that in 2001?
Keep it short and to the point. 0.92. What is the ratio of the Exports in Gambia, The in 2000 to that in 2001?
Ensure brevity in your answer.  1.21. What is the ratio of the Exports in Haiti in 2000 to that in 2001?
Offer a very short reply. 1.02. What is the ratio of the Exports of Samoa in 2000 to that in 2001?
Your answer should be very brief. 0.91. What is the difference between the highest and the second highest Exports in Djibouti?
Offer a very short reply. 2.95e+09. What is the difference between the highest and the second highest Exports of Gambia, The?
Your response must be concise. 5.28e+08. What is the difference between the highest and the second highest Exports in Haiti?
Offer a terse response. 6.40e+07. What is the difference between the highest and the second highest Exports of Samoa?
Ensure brevity in your answer.  9.18e+06. What is the difference between the highest and the lowest Exports in Djibouti?
Offer a very short reply. 6.30e+09. What is the difference between the highest and the lowest Exports in Gambia, The?
Offer a very short reply. 1.93e+09. What is the difference between the highest and the lowest Exports of Haiti?
Keep it short and to the point. 1.96e+09. What is the difference between the highest and the lowest Exports of Samoa?
Your answer should be compact. 1.55e+08. 